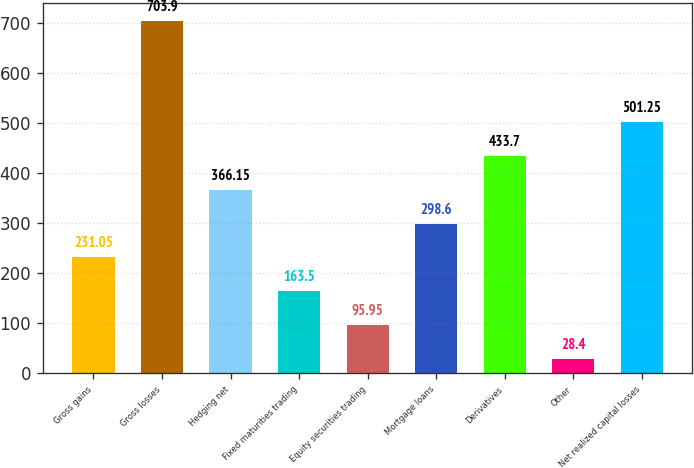Convert chart. <chart><loc_0><loc_0><loc_500><loc_500><bar_chart><fcel>Gross gains<fcel>Gross losses<fcel>Hedging net<fcel>Fixed maturities trading<fcel>Equity securities trading<fcel>Mortgage loans<fcel>Derivatives<fcel>Other<fcel>Net realized capital losses<nl><fcel>231.05<fcel>703.9<fcel>366.15<fcel>163.5<fcel>95.95<fcel>298.6<fcel>433.7<fcel>28.4<fcel>501.25<nl></chart> 